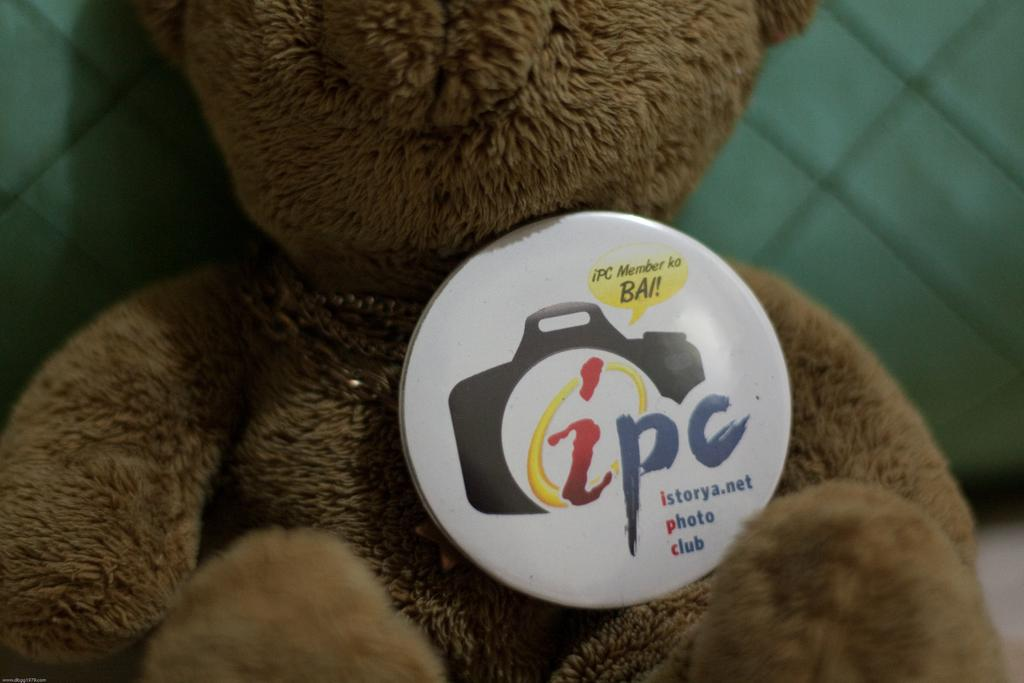What is the main object in the image? There is a teddy bear in the image. Does the teddy bear have any distinguishing features? Yes, the teddy bear has a badge. Can you tell me how many lakes are visible in the image? There are no lakes present in the image; it features a teddy bear with a badge. What type of surprise can be seen coming out of the teddy bear's pocket in the image? There is no surprise or pocket visible on the teddy bear in the image. 